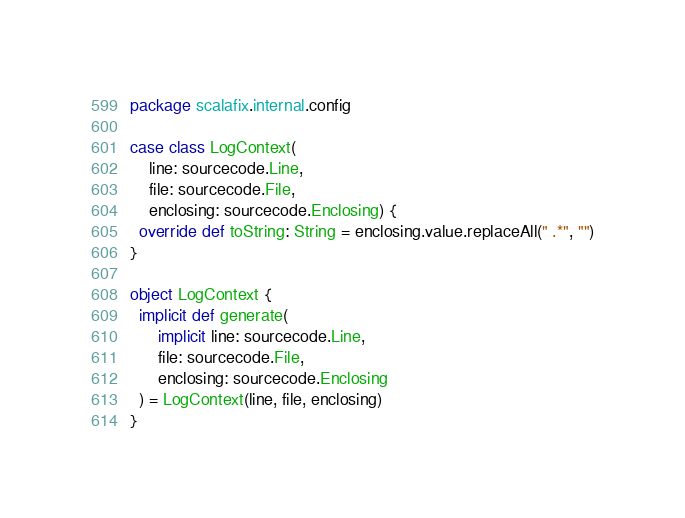Convert code to text. <code><loc_0><loc_0><loc_500><loc_500><_Scala_>package scalafix.internal.config

case class LogContext(
    line: sourcecode.Line,
    file: sourcecode.File,
    enclosing: sourcecode.Enclosing) {
  override def toString: String = enclosing.value.replaceAll(" .*", "")
}

object LogContext {
  implicit def generate(
      implicit line: sourcecode.Line,
      file: sourcecode.File,
      enclosing: sourcecode.Enclosing
  ) = LogContext(line, file, enclosing)
}
</code> 